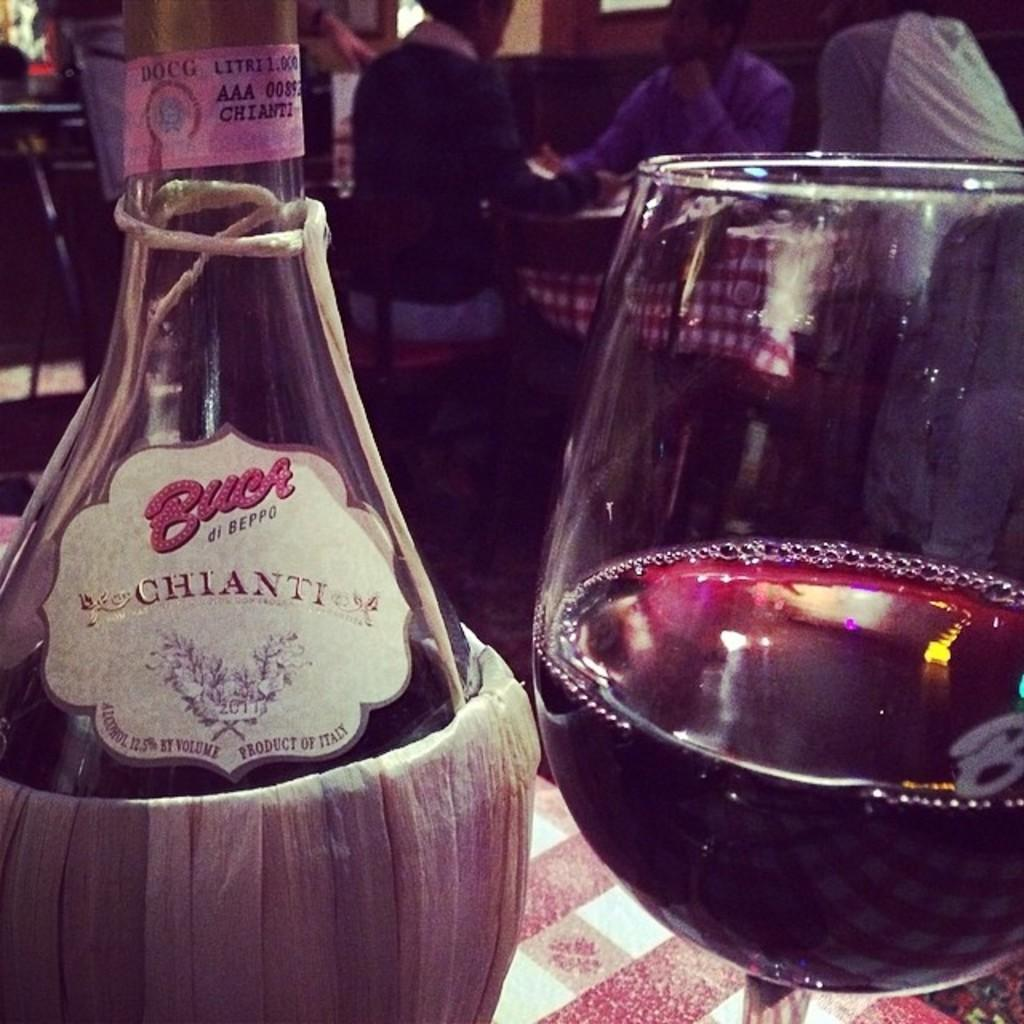What is one object visible in the image? There is a bottle in the image. What is another object visible in the image? There is a glass in the image. What type of curtain is hanging in the background of the image? There is no curtain present in the image; it only features a bottle and a glass. What type of shop is visible in the image? There is no shop present in the image; it only features a bottle and a glass. 